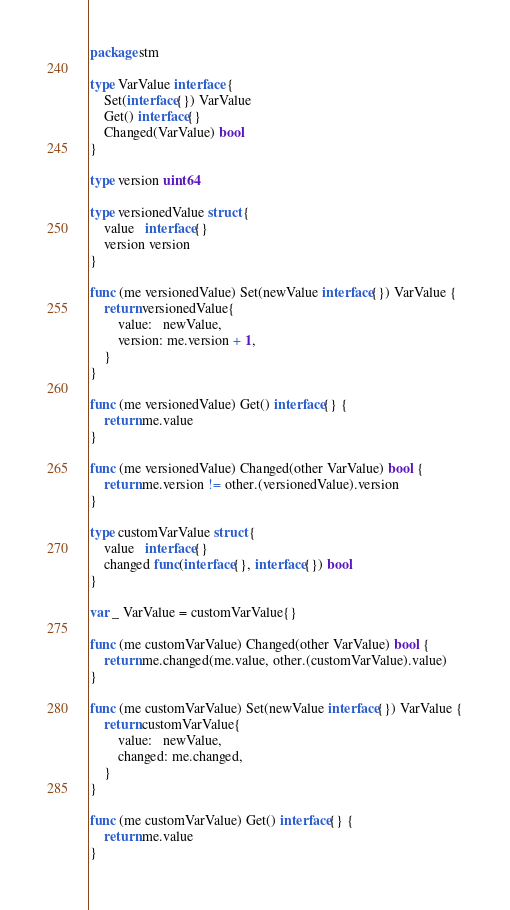Convert code to text. <code><loc_0><loc_0><loc_500><loc_500><_Go_>package stm

type VarValue interface {
	Set(interface{}) VarValue
	Get() interface{}
	Changed(VarValue) bool
}

type version uint64

type versionedValue struct {
	value   interface{}
	version version
}

func (me versionedValue) Set(newValue interface{}) VarValue {
	return versionedValue{
		value:   newValue,
		version: me.version + 1,
	}
}

func (me versionedValue) Get() interface{} {
	return me.value
}

func (me versionedValue) Changed(other VarValue) bool {
	return me.version != other.(versionedValue).version
}

type customVarValue struct {
	value   interface{}
	changed func(interface{}, interface{}) bool
}

var _ VarValue = customVarValue{}

func (me customVarValue) Changed(other VarValue) bool {
	return me.changed(me.value, other.(customVarValue).value)
}

func (me customVarValue) Set(newValue interface{}) VarValue {
	return customVarValue{
		value:   newValue,
		changed: me.changed,
	}
}

func (me customVarValue) Get() interface{} {
	return me.value
}
</code> 